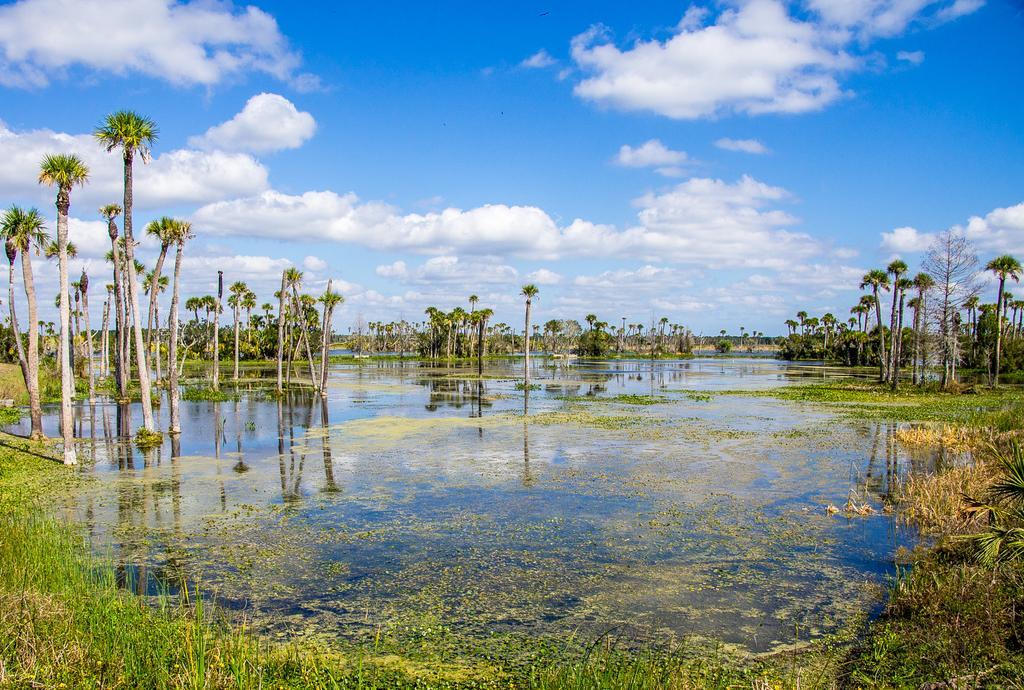Describe this image in one or two sentences. In this image there is grass on the water which is in front. In the center there is water. In the background there are trees and the sky is cloudy. 